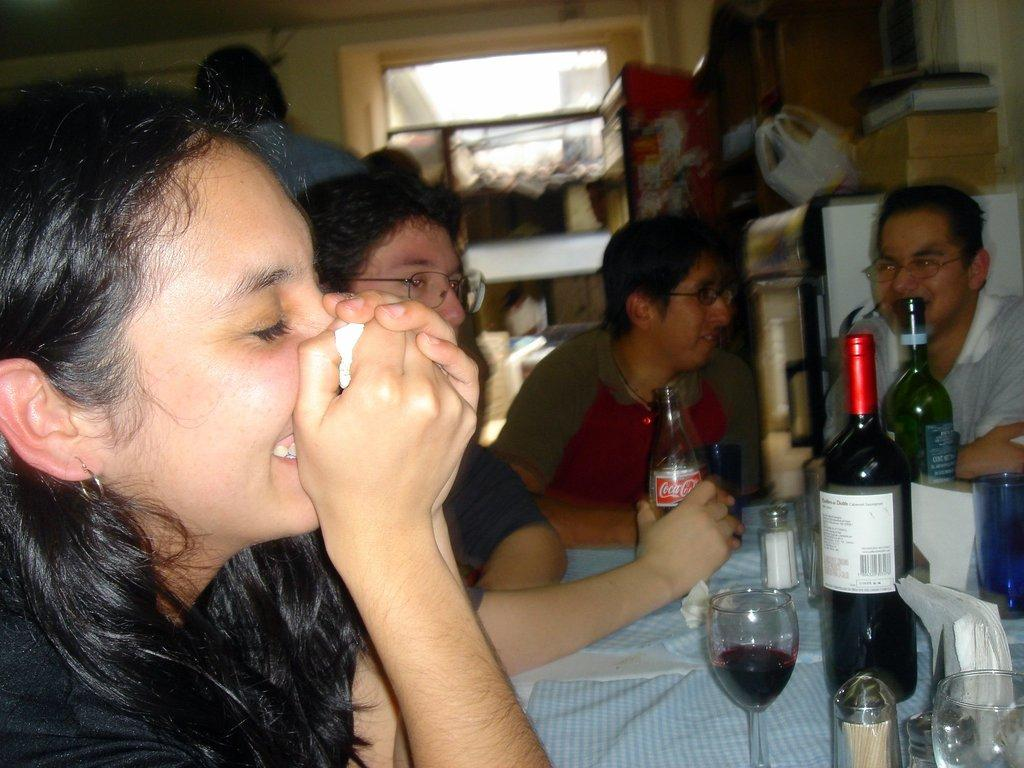How many people are present in the image? There are four people in the image. What are the people doing in the image? The people are sitting on chairs. How are the chairs arranged in the image? The chairs are arranged around a table. What can be seen on the table in the image? There are glasses and a bottle on the table. What is visible in the background of the image? There is a fridge in the background of the image. Are there any cherries on the table in the image? There is no mention of cherries in the image; only glasses and a bottle are present on the table. Can you see a cub or a wrench in the image? There is no mention of a cub or a wrench in the image. 